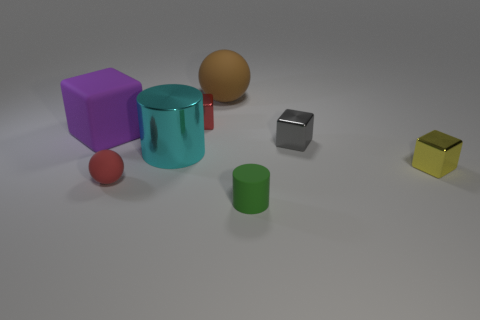Do any of these objects share the same color? From the visible objects, none share the exact same color. Each object has its own distinct color. 